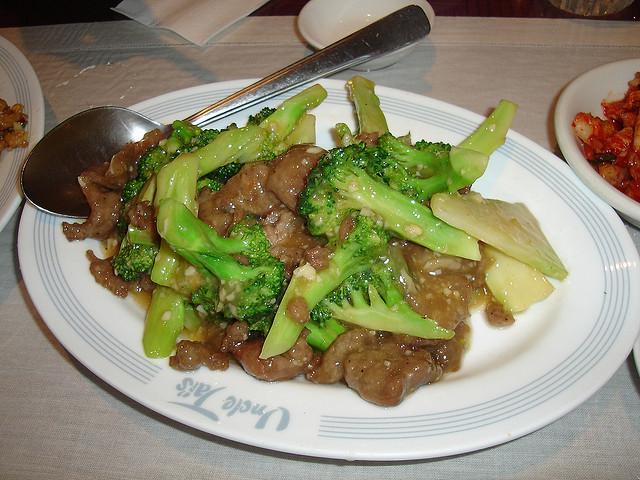What is the utensil shown?
Answer briefly. Spoon. Is there broccoli in the photo?
Keep it brief. Yes. What are the green items?
Concise answer only. Broccoli. Is there cheese?
Short answer required. No. Is this dish spicy?
Answer briefly. No. Is this a healthy well balanced meal?
Short answer required. Yes. What is the text etched in the edge of the plate?
Answer briefly. Uncle tai's. 